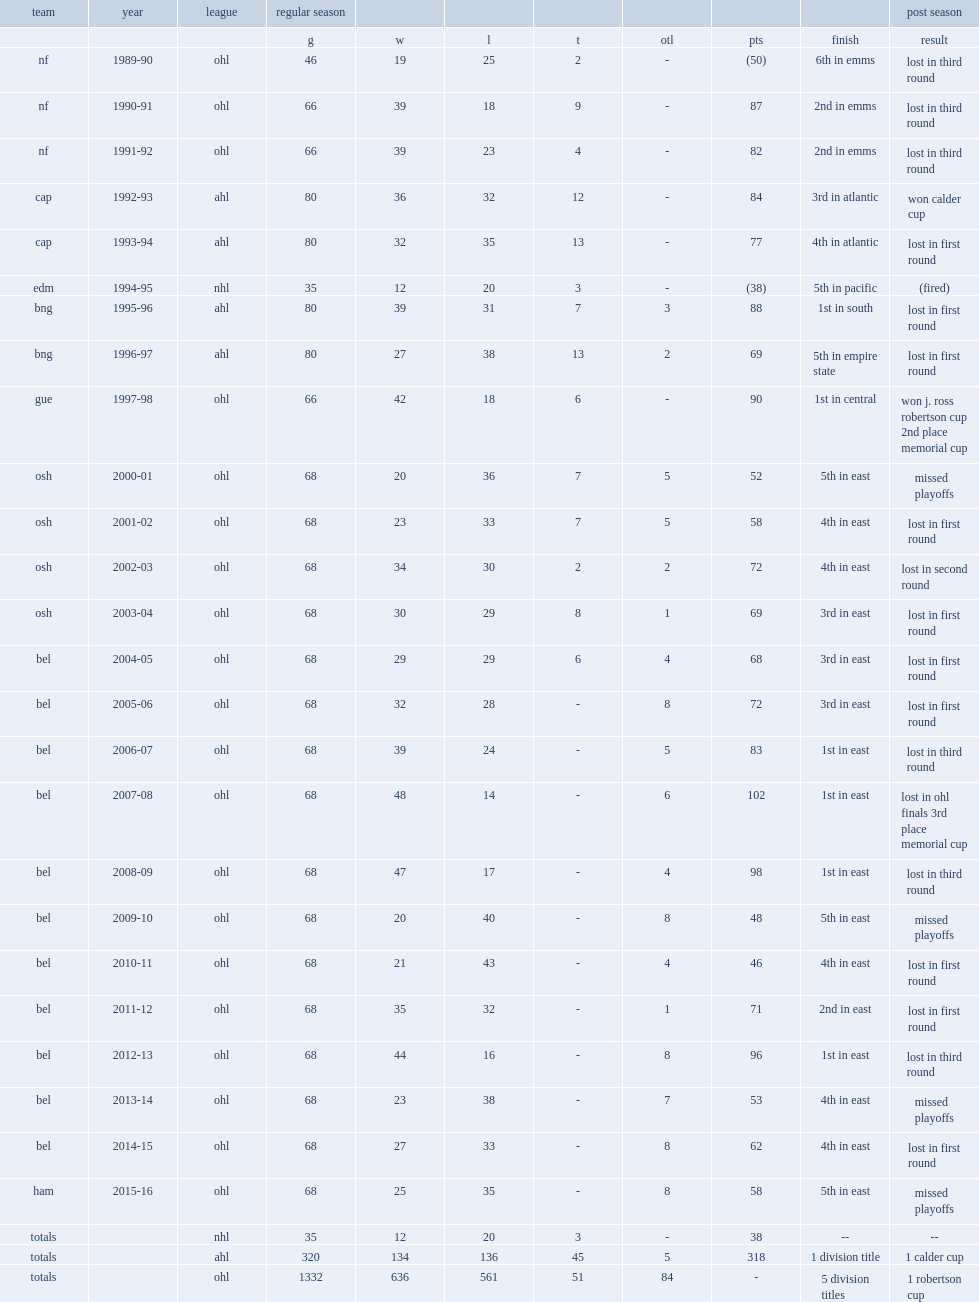How many games did burnett coach in the ohl totally? 1332.0. 